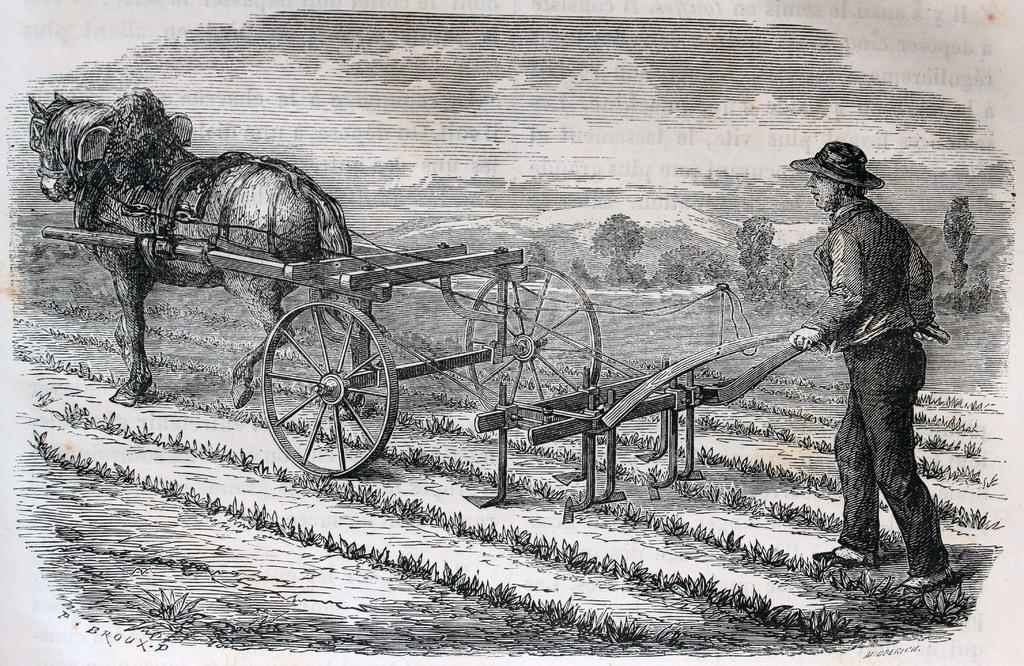What is depicted in the sketch in the image? The sketch in the image contains a man and a horse. What are the man and horse doing in the sketch? The man and horse are ploughing the land in the sketch. What is the man wearing on his head in the sketch? The man is wearing a hat on his head in the sketch. What is the color scheme of the image? The image is black and white. What type of umbrella is the fireman holding while ploughing the land in the image? There is no fireman or umbrella present in the image. The image features a man and a horse ploughing the land, and the man is wearing a hat, not an umbrella. 